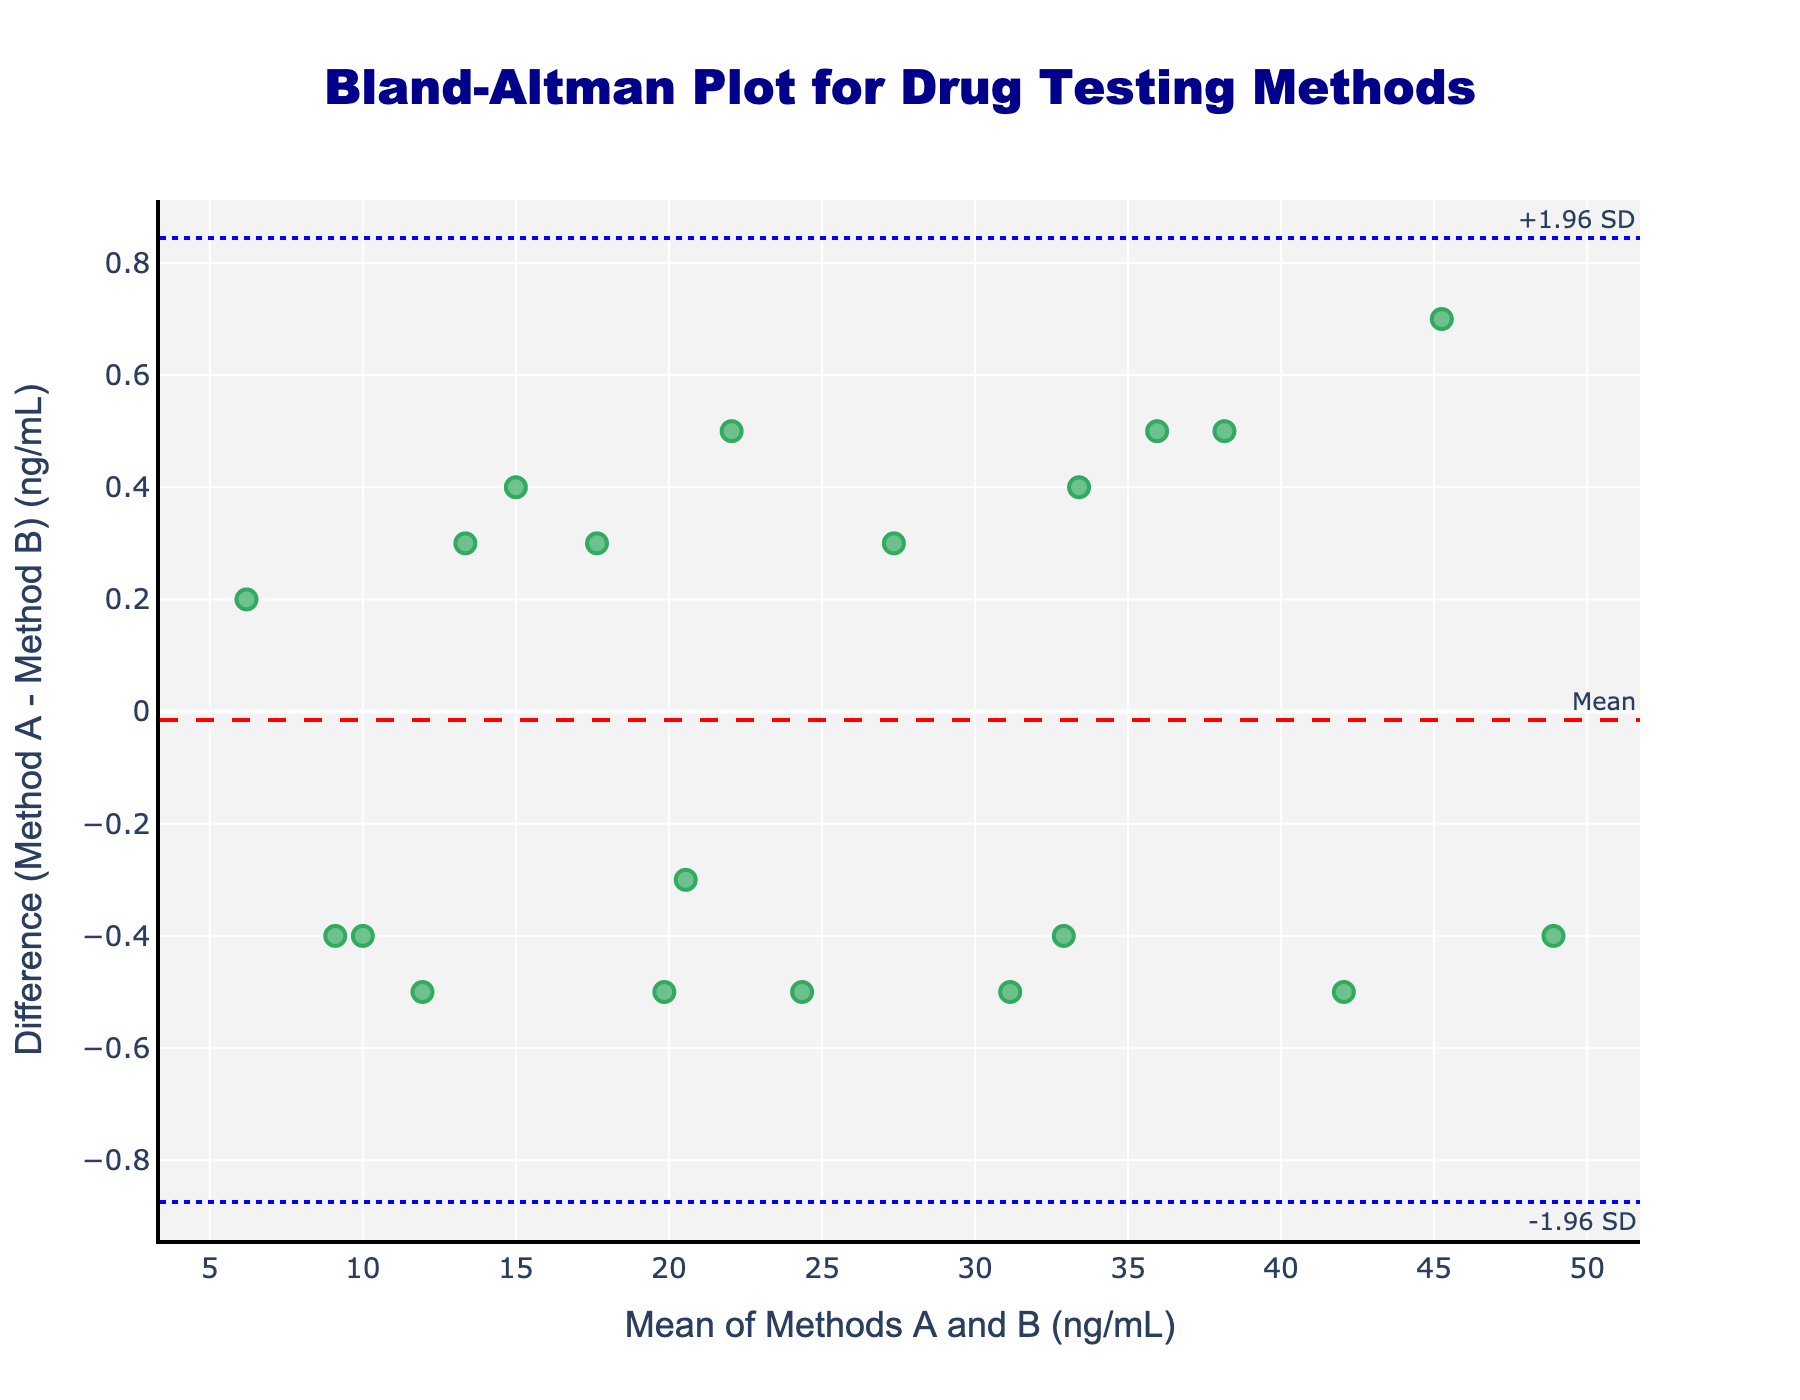What is the title of the figure? The title is displayed at the top and centered, indicating the content of the figure.
Answer: Bland-Altman Plot for Drug Testing Methods What do the x-axis and y-axis represent? The x-axis title states "Mean of Methods A and B (ng/mL)" which shows the average measurement values from both methods. The y-axis title reads "Difference (Method A - Method B) (ng/mL)" indicating the difference between the measurements from both methods.
Answer: The x-axis represents the mean of Methods A and B, and the y-axis represents the difference (Method A - Method B) in ng/mL How many data points are plotted in the scatter plot? Each data point corresponds to a measurement comparison between the two methods. Counting these data points helps determine the sample size used. There are 20 measurement pairs, resulting in 20 data points.
Answer: 20 What color is used for the mean difference line? A dashed line in red is used to show the mean difference. The color helps distinguish this line from others.
Answer: Red What are the values of the upper and lower limits of agreement (LOA)? The limits of agreement are represented by the dotted blue lines, the exact values can be read off from the y-axis where these lines intersect. These lines represent ±1.96 standard deviations from the mean difference.
Answer: Upper and lower LOA values should be calculated with the exact data provided: the mean difference and standard deviation values are needed What does it mean if a data point falls outside the limits of agreement? Data points outside the limits of agreement indicate significant discrepancies between the two methods, suggesting that they might not agree well for those particular measurements.
Answer: It means there's a significant discrepancy Which axis measures the central tendency of both methods' values? The x-axis measures the central tendency by showing the mean of the measurement values from both methods.
Answer: X-axis Are any points noticeably far from the mean difference line? Observing this helps identify outlier points which significantly deviate from the average difference between the methods.
Answer: Yes Is there any pattern you notice in the distribution of the differences, such as systematic bias? Systematic bias can be observed if most points consistently fall above or below the mean difference line, suggesting one method consistently over or underestimates compared to the other.
Answer: (Explanation depends on observing the plot, e.g., "Yes, there's a slight upward trend" or "No clear pattern seen.") Compare the variability of differences at lower mean values versus higher mean values. Notice if data points are more spread out or consistent as the mean values increase or decrease across the x-axis, providing insight into measurement consistency between the methods.
Answer: (Description depends on pattern seen, e.g., "Differences show more variability at higher mean values.") 